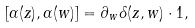Convert formula to latex. <formula><loc_0><loc_0><loc_500><loc_500>[ \alpha ( z ) , \alpha ( w ) ] = \partial _ { w } \delta ( z , w ) \cdot 1 ,</formula> 